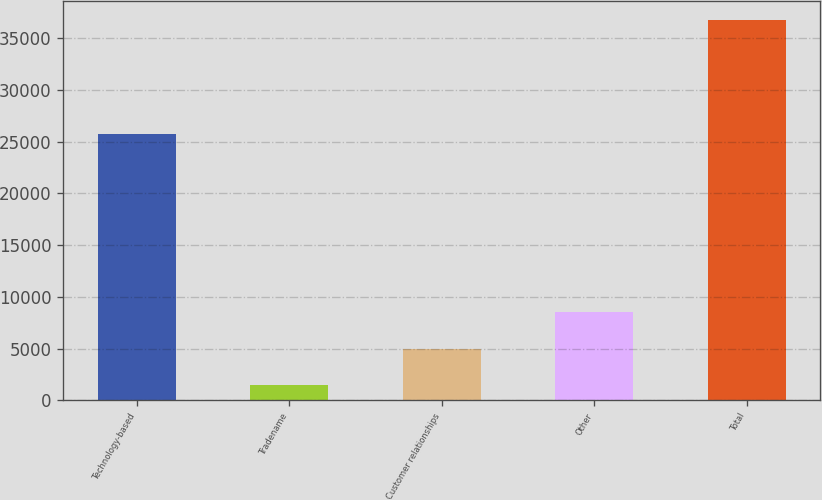Convert chart to OTSL. <chart><loc_0><loc_0><loc_500><loc_500><bar_chart><fcel>Technology-based<fcel>Tradename<fcel>Customer relationships<fcel>Other<fcel>Total<nl><fcel>25731<fcel>1430<fcel>4958.7<fcel>8487.4<fcel>36717<nl></chart> 